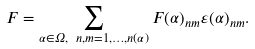Convert formula to latex. <formula><loc_0><loc_0><loc_500><loc_500>F = \sum _ { \alpha \in \Omega , \ n , m = 1 , \dots , n ( \alpha ) } F ( \alpha ) _ { n m } \varepsilon ( \alpha ) _ { n m } .</formula> 